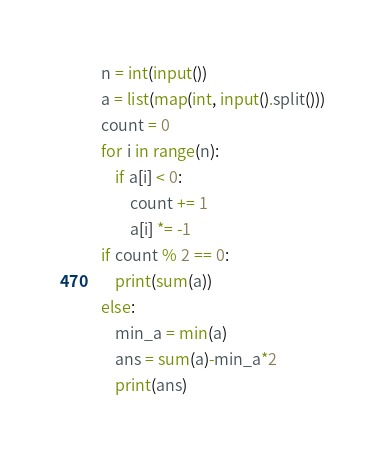<code> <loc_0><loc_0><loc_500><loc_500><_Python_>n = int(input())
a = list(map(int, input().split()))
count = 0
for i in range(n):
    if a[i] < 0:
        count += 1
        a[i] *= -1
if count % 2 == 0:
    print(sum(a))
else:
    min_a = min(a)
    ans = sum(a)-min_a*2
    print(ans)

</code> 